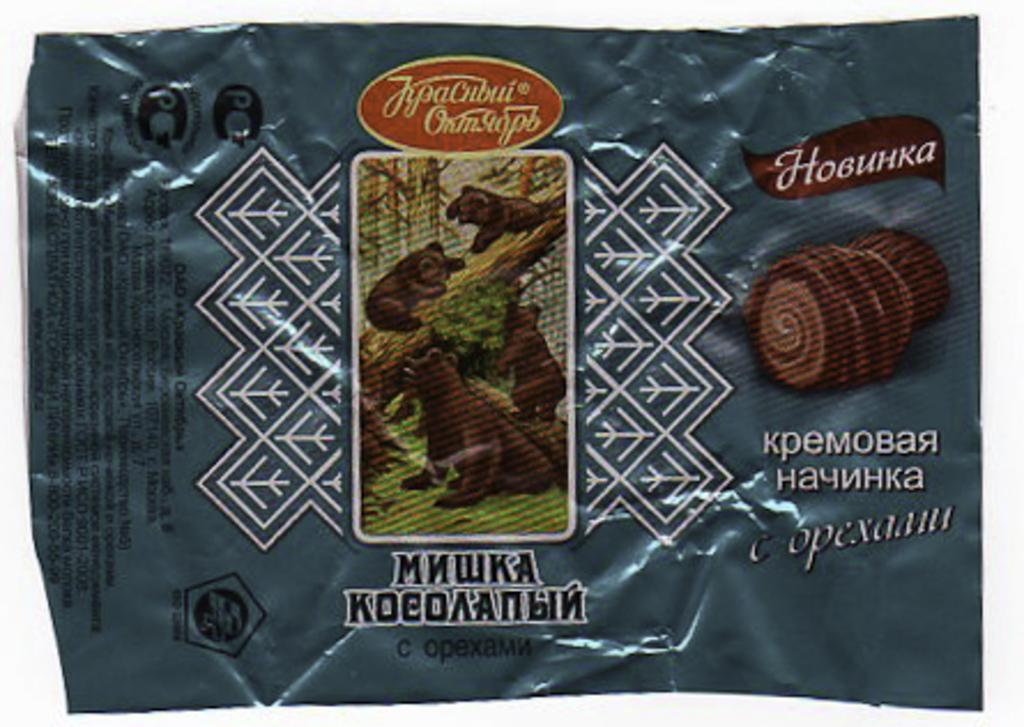What is the main object in the image? There is a cover in the image. What can be found on the cover? There are texts and images of animals on the cover. What kind of trouble did the son get into in the image? There is no son or trouble present in the image; it only features a cover with texts and images of animals. 